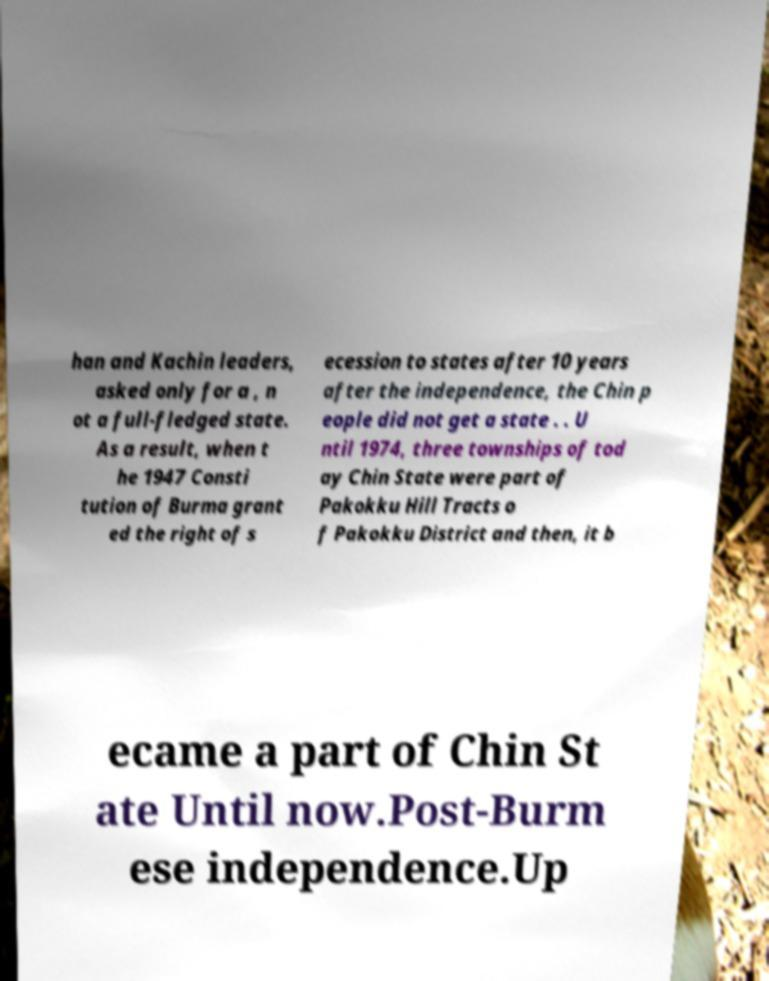Can you read and provide the text displayed in the image?This photo seems to have some interesting text. Can you extract and type it out for me? han and Kachin leaders, asked only for a , n ot a full-fledged state. As a result, when t he 1947 Consti tution of Burma grant ed the right of s ecession to states after 10 years after the independence, the Chin p eople did not get a state . . U ntil 1974, three townships of tod ay Chin State were part of Pakokku Hill Tracts o f Pakokku District and then, it b ecame a part of Chin St ate Until now.Post-Burm ese independence.Up 